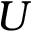Convert formula to latex. <formula><loc_0><loc_0><loc_500><loc_500>U</formula> 